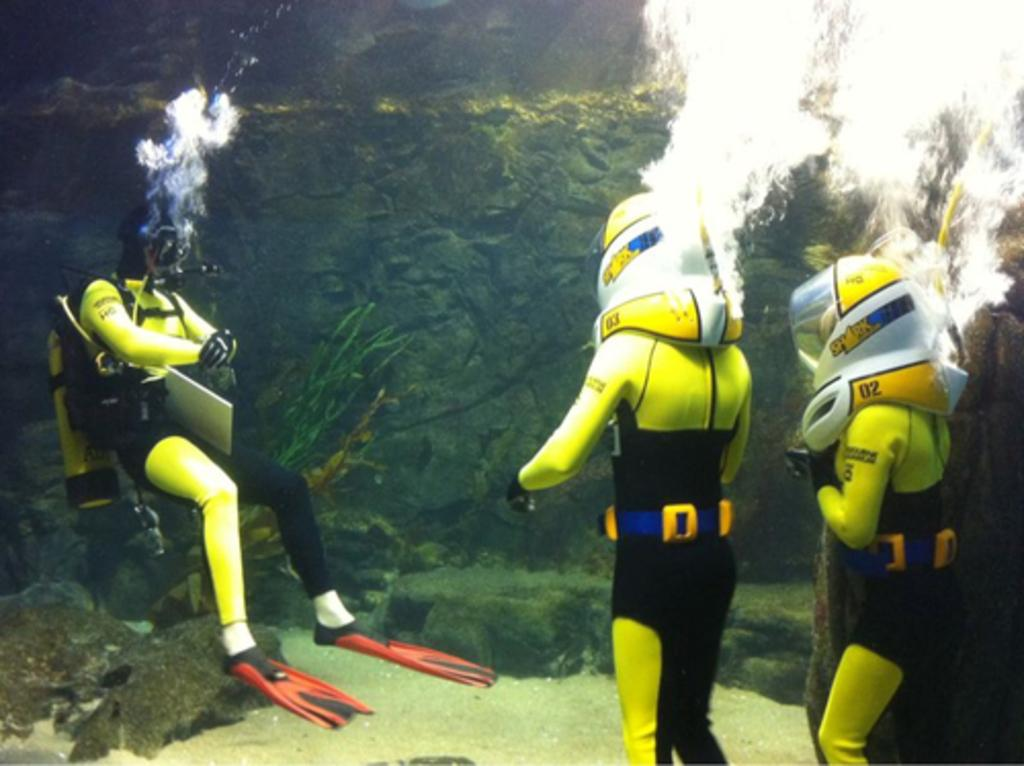<image>
Provide a brief description of the given image. Several divers are underwater and wearing large helmets with one having 02 printed on the side of it. 